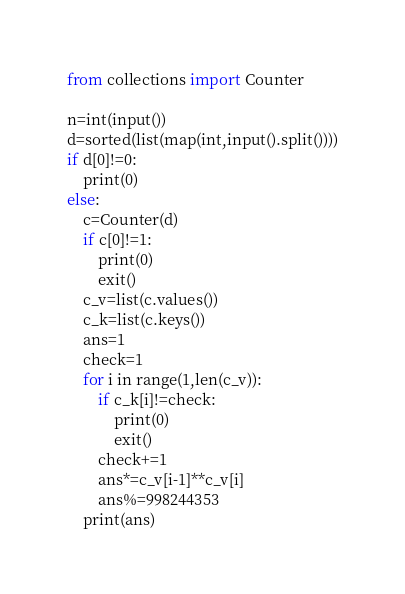Convert code to text. <code><loc_0><loc_0><loc_500><loc_500><_Python_>from collections import Counter

n=int(input())
d=sorted(list(map(int,input().split())))
if d[0]!=0:
    print(0)
else:
    c=Counter(d)
    if c[0]!=1:
        print(0)
        exit()
    c_v=list(c.values())
    c_k=list(c.keys())
    ans=1
    check=1
    for i in range(1,len(c_v)):
        if c_k[i]!=check:
            print(0)
            exit()
        check+=1
        ans*=c_v[i-1]**c_v[i]
        ans%=998244353
    print(ans)</code> 